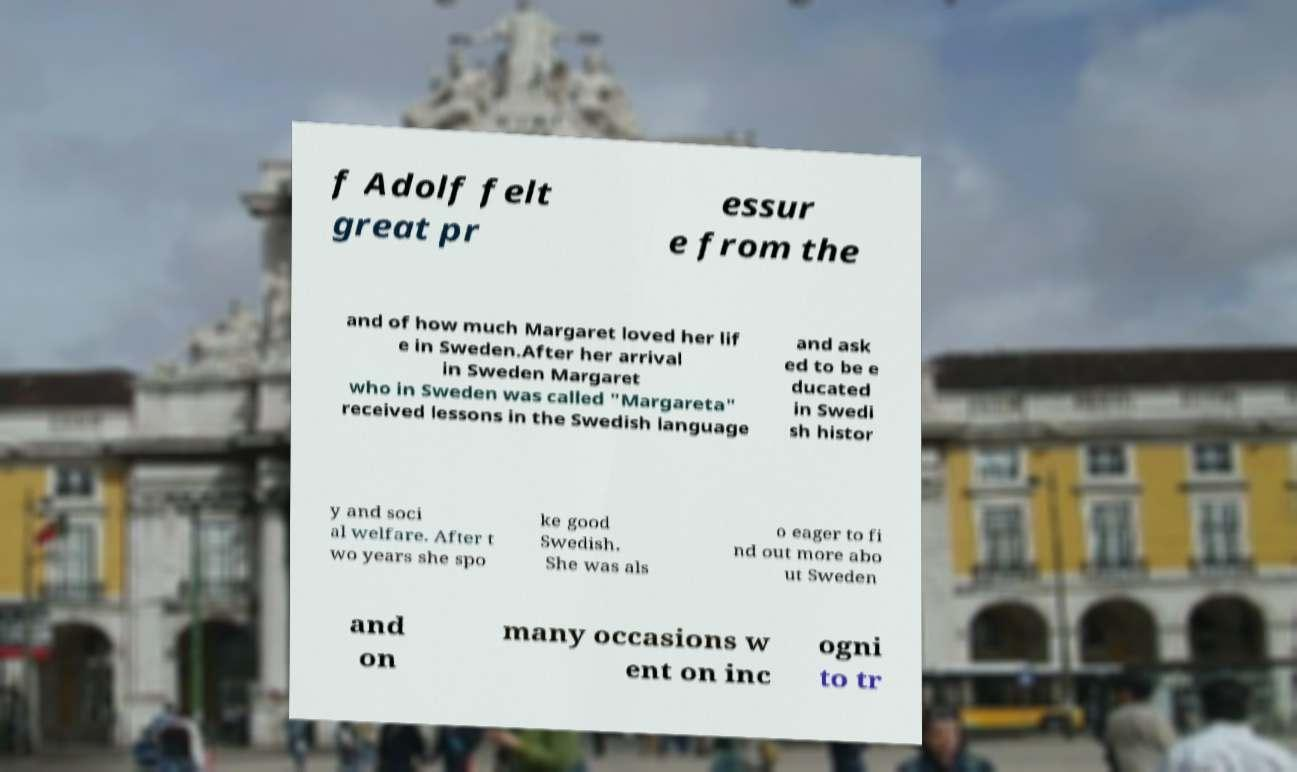Please read and relay the text visible in this image. What does it say? f Adolf felt great pr essur e from the and of how much Margaret loved her lif e in Sweden.After her arrival in Sweden Margaret who in Sweden was called "Margareta" received lessons in the Swedish language and ask ed to be e ducated in Swedi sh histor y and soci al welfare. After t wo years she spo ke good Swedish. She was als o eager to fi nd out more abo ut Sweden and on many occasions w ent on inc ogni to tr 